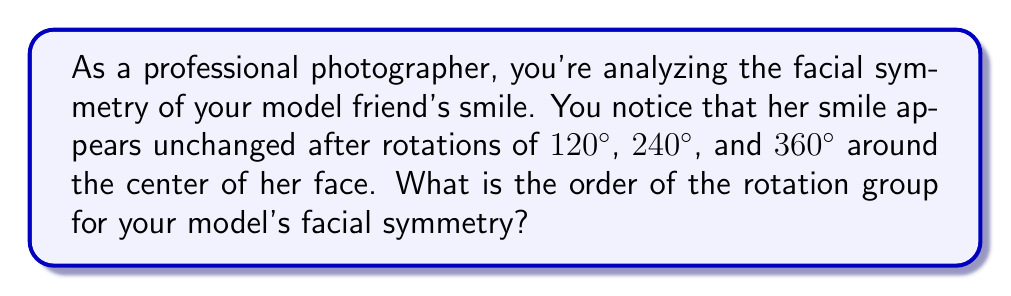Can you answer this question? Let's approach this step-by-step:

1) In abstract algebra, the order of a group is the number of elements in the group. For rotation groups, this corresponds to the number of distinct rotations that leave the object (in this case, the smile) unchanged.

2) We're given that the smile appears unchanged after rotations of 120°, 240°, and 360°. Let's call the rotation operation $r$.

3) We can represent these rotations as:
   $r^1 = 120°$ rotation
   $r^2 = 240°$ rotation
   $r^3 = 360°$ rotation = identity

4) The fact that $r^3$ brings us back to the starting position (360° or 0°) is key. This means that $r^3 = e$, where $e$ is the identity element.

5) We can generate all elements of the group by applying $r$ repeatedly:
   $e = r^0 = r^3$ (identity, no rotation)
   $r^1 = 120°$ rotation
   $r^2 = 240°$ rotation

6) Any further applications of $r$ will cycle through these same elements:
   $r^4 = r^1$ (120° rotation)
   $r^5 = r^2$ (240° rotation)
   $r^6 = r^3 = e$ (360° rotation, back to identity)

7) Therefore, the group has 3 distinct elements: $\{e, r, r^2\}$

8) In group theory, this is known as the cyclic group of order 3, often denoted as $C_3$ or $\mathbb{Z}_3$.
Answer: The order of the rotation group for the model's facial symmetry is 3. 